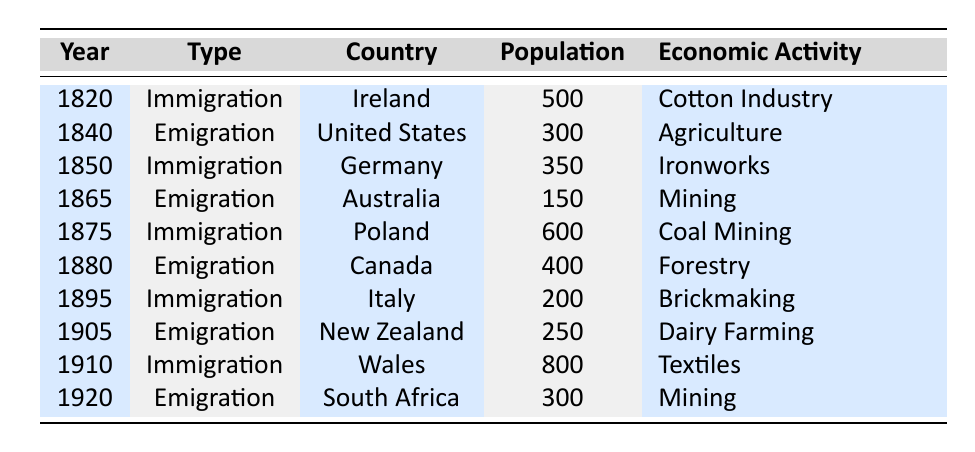What was the estimated population of immigrants from Poland in 1875? The table states that in 1875, there were 600 immigrants from Poland.
Answer: 600 How many people emigrated to the United States in 1840? According to the table, 300 individuals emigrated to the United States in 1840.
Answer: 300 What was the primary economic activity for immigrants from Italy in 1895? The table indicates that the economic activity for immigrants from Italy in 1895 was Brickmaking.
Answer: Brickmaking Which year saw the highest number of immigrants and what was their country of origin? In 1910, there were 800 immigrants from Wales, which is the highest number listed in the table.
Answer: 1910, Wales Calculate the total estimated population of immigrants from Ireland and Germany combined. The estimated population from Ireland in 1820 is 500 and from Germany in 1850 is 350. Adding these two gives 500 + 350 = 850.
Answer: 850 How many more people emigrated to Canada in 1880 compared to those who emigrated to Australia in 1865? The table shows 400 people emigrated to Canada in 1880 and 150 to Australia in 1865. The difference is 400 - 150 = 250.
Answer: 250 Did any country have a higher number of immigrants than emigrants in the years presented in the table? Yes, in 1910, there were 800 immigrants from Wales, which is higher than any number of emigrants listed.
Answer: Yes Which economic activity was most common among emigrants, based on the years covered in the table? The most common economic activity among emigrants, as per the table, is Mining, which appears for emigrants to both Australia (1865) and South Africa (1920).
Answer: Mining Calculate the average estimated population of immigrants listed in the table. The total immigrant population from the given years is 500 (Ireland) + 350 (Germany) + 600 (Poland) + 200 (Italy) + 800 (Wales) = 2450. There are 5 entries for immigration, so the average is 2450 / 5 = 490.
Answer: 490 What was the economic activity associated with the highest number of immigrants? The highest number of immigrants was associated with the economic activity 'Textiles' in 1910, with 800 immigrants.
Answer: Textiles 